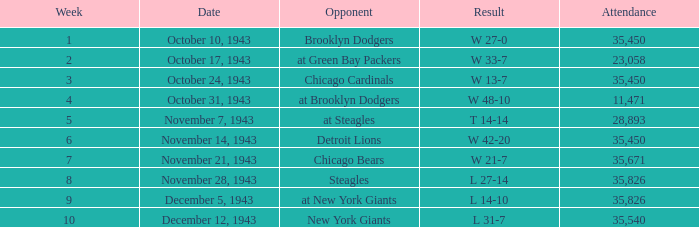How many attendances have 9 as the week? 1.0. 